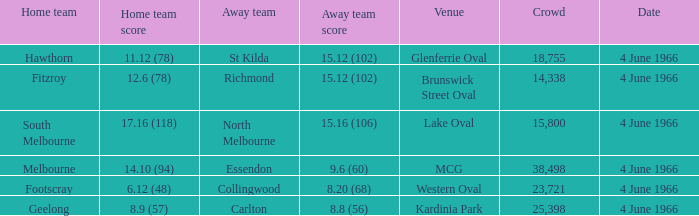Can you give me this table as a dict? {'header': ['Home team', 'Home team score', 'Away team', 'Away team score', 'Venue', 'Crowd', 'Date'], 'rows': [['Hawthorn', '11.12 (78)', 'St Kilda', '15.12 (102)', 'Glenferrie Oval', '18,755', '4 June 1966'], ['Fitzroy', '12.6 (78)', 'Richmond', '15.12 (102)', 'Brunswick Street Oval', '14,338', '4 June 1966'], ['South Melbourne', '17.16 (118)', 'North Melbourne', '15.16 (106)', 'Lake Oval', '15,800', '4 June 1966'], ['Melbourne', '14.10 (94)', 'Essendon', '9.6 (60)', 'MCG', '38,498', '4 June 1966'], ['Footscray', '6.12 (48)', 'Collingwood', '8.20 (68)', 'Western Oval', '23,721', '4 June 1966'], ['Geelong', '8.9 (57)', 'Carlton', '8.8 (56)', 'Kardinia Park', '25,398', '4 June 1966']]} What is the largest crowd size that watch a game where the home team scored 12.6 (78)? 14338.0. 